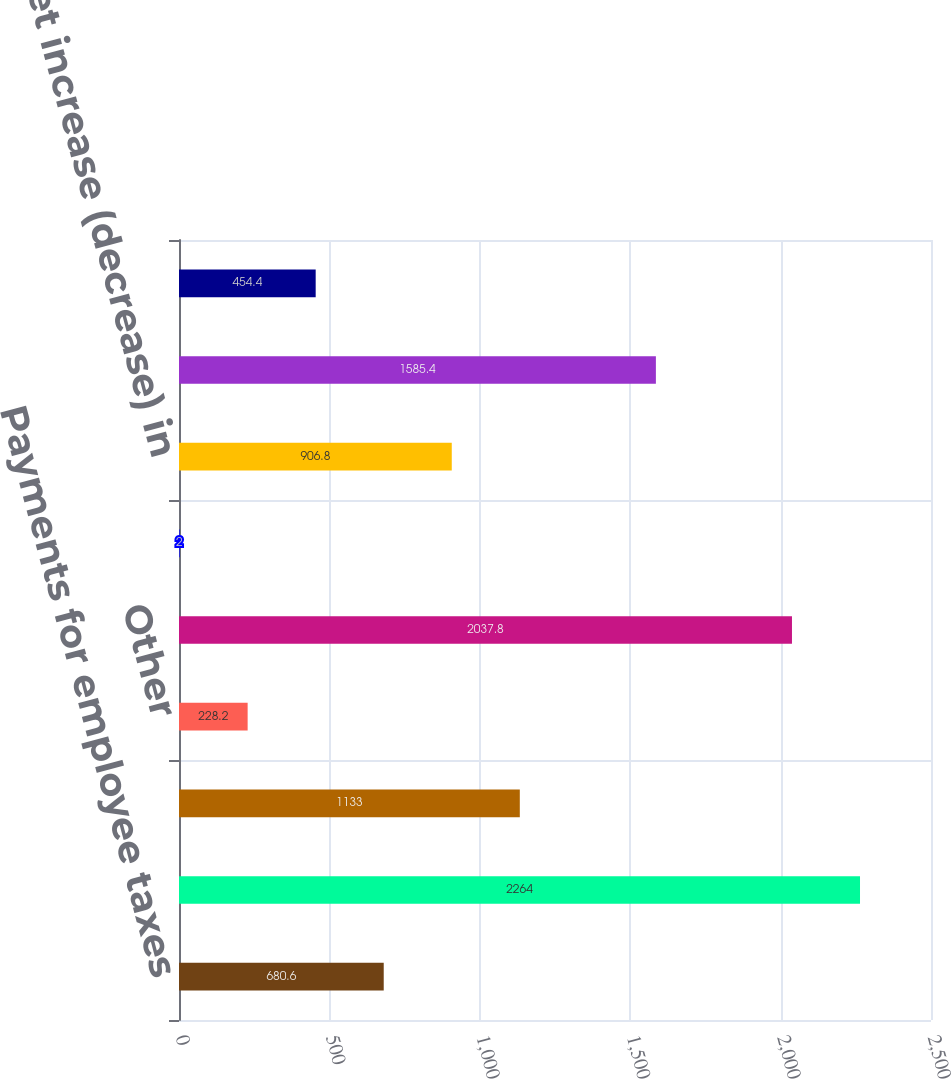Convert chart to OTSL. <chart><loc_0><loc_0><loc_500><loc_500><bar_chart><fcel>Payments for employee taxes<fcel>Cash paid for purchases of<fcel>Dividends and dividend rights<fcel>Other<fcel>Net cash used in financing<fcel>Effect of exchange rates on<fcel>Net increase (decrease) in<fcel>Cash and cash equivalents at<fcel>Interest paid<nl><fcel>680.6<fcel>2264<fcel>1133<fcel>228.2<fcel>2037.8<fcel>2<fcel>906.8<fcel>1585.4<fcel>454.4<nl></chart> 